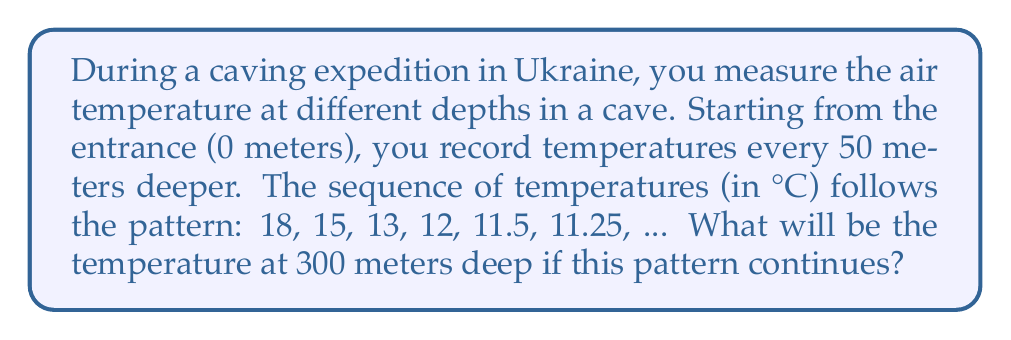Teach me how to tackle this problem. Let's analyze the sequence step-by-step:

1) First, calculate the differences between consecutive terms:
   18 - 15 = 3
   15 - 13 = 2
   13 - 12 = 1
   12 - 11.5 = 0.5
   11.5 - 11.25 = 0.25

2) We can see that each difference is half of the previous one. This forms a geometric sequence with a common ratio of $\frac{1}{2}$.

3) The general term for this type of sequence can be expressed as:
   $$a_n = a_1 - \sum_{i=1}^{n-1} 3 \cdot (\frac{1}{2})^{i-1}$$
   Where $a_1 = 18$ (the initial temperature) and $n$ is the term number.

4) To find the temperature at 300 meters, we need the 7th term (as 300/50 + 1 = 7).

5) Let's calculate:
   $$a_7 = 18 - (3 + 1.5 + 0.75 + 0.375 + 0.1875 + 0.09375)$$
   $$a_7 = 18 - 5.90625 = 12.09375$$

6) Therefore, the temperature at 300 meters deep will be 12.09375°C.
Answer: 12.09375°C 